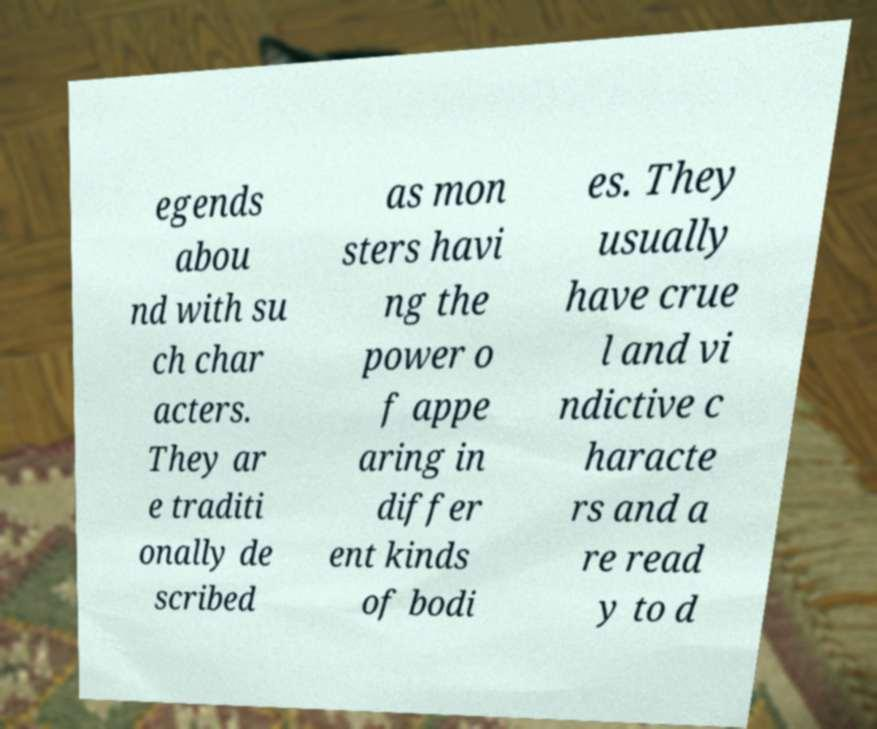I need the written content from this picture converted into text. Can you do that? egends abou nd with su ch char acters. They ar e traditi onally de scribed as mon sters havi ng the power o f appe aring in differ ent kinds of bodi es. They usually have crue l and vi ndictive c haracte rs and a re read y to d 